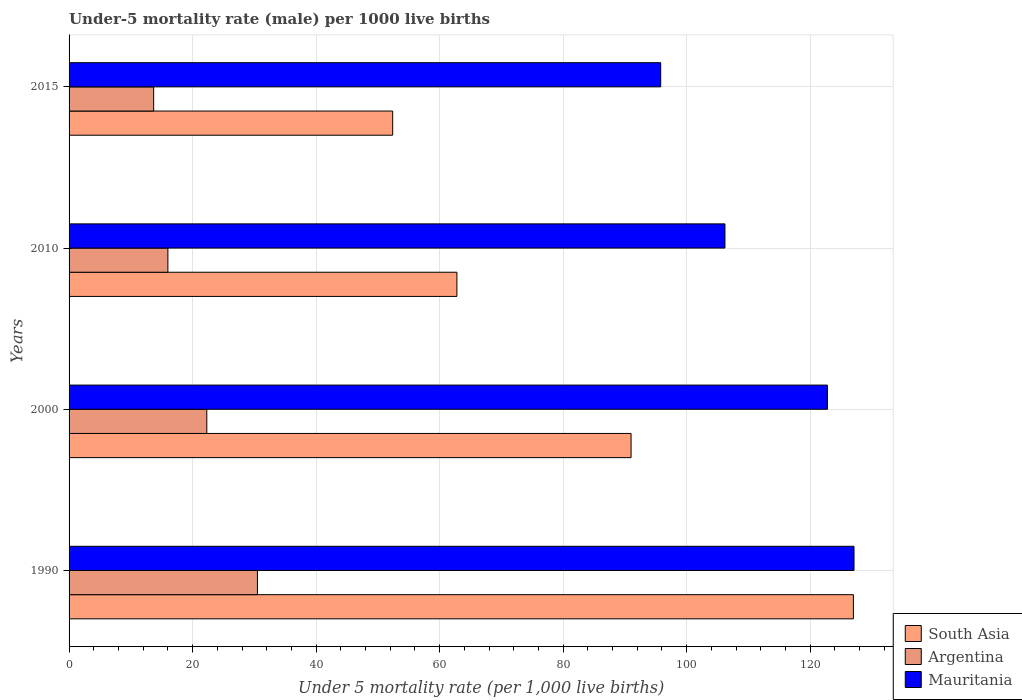Are the number of bars per tick equal to the number of legend labels?
Make the answer very short. Yes. In how many cases, is the number of bars for a given year not equal to the number of legend labels?
Provide a short and direct response. 0. What is the under-five mortality rate in Argentina in 1990?
Ensure brevity in your answer.  30.5. Across all years, what is the maximum under-five mortality rate in Argentina?
Give a very brief answer. 30.5. In which year was the under-five mortality rate in Mauritania maximum?
Your response must be concise. 1990. In which year was the under-five mortality rate in South Asia minimum?
Provide a succinct answer. 2015. What is the total under-five mortality rate in Argentina in the graph?
Provide a short and direct response. 82.5. What is the difference between the under-five mortality rate in Argentina in 1990 and that in 2010?
Your answer should be very brief. 14.5. What is the difference between the under-five mortality rate in South Asia in 2000 and the under-five mortality rate in Argentina in 2015?
Provide a succinct answer. 77.3. What is the average under-five mortality rate in Mauritania per year?
Your answer should be very brief. 112.97. In the year 2000, what is the difference between the under-five mortality rate in South Asia and under-five mortality rate in Mauritania?
Give a very brief answer. -31.8. What is the ratio of the under-five mortality rate in Argentina in 2000 to that in 2010?
Your answer should be compact. 1.39. Is the under-five mortality rate in Mauritania in 1990 less than that in 2010?
Your answer should be compact. No. What is the difference between the highest and the second highest under-five mortality rate in Argentina?
Provide a succinct answer. 8.2. What is the difference between the highest and the lowest under-five mortality rate in Argentina?
Offer a very short reply. 16.8. In how many years, is the under-five mortality rate in South Asia greater than the average under-five mortality rate in South Asia taken over all years?
Make the answer very short. 2. What does the 1st bar from the top in 2000 represents?
Ensure brevity in your answer.  Mauritania. How many bars are there?
Keep it short and to the point. 12. Are the values on the major ticks of X-axis written in scientific E-notation?
Make the answer very short. No. Does the graph contain grids?
Your answer should be very brief. Yes. Where does the legend appear in the graph?
Your answer should be very brief. Bottom right. How are the legend labels stacked?
Provide a succinct answer. Vertical. What is the title of the graph?
Keep it short and to the point. Under-5 mortality rate (male) per 1000 live births. What is the label or title of the X-axis?
Your answer should be compact. Under 5 mortality rate (per 1,0 live births). What is the Under 5 mortality rate (per 1,000 live births) in South Asia in 1990?
Your answer should be compact. 127. What is the Under 5 mortality rate (per 1,000 live births) of Argentina in 1990?
Keep it short and to the point. 30.5. What is the Under 5 mortality rate (per 1,000 live births) in Mauritania in 1990?
Your response must be concise. 127.1. What is the Under 5 mortality rate (per 1,000 live births) of South Asia in 2000?
Provide a succinct answer. 91. What is the Under 5 mortality rate (per 1,000 live births) in Argentina in 2000?
Your answer should be very brief. 22.3. What is the Under 5 mortality rate (per 1,000 live births) in Mauritania in 2000?
Make the answer very short. 122.8. What is the Under 5 mortality rate (per 1,000 live births) in South Asia in 2010?
Make the answer very short. 62.8. What is the Under 5 mortality rate (per 1,000 live births) in Argentina in 2010?
Your response must be concise. 16. What is the Under 5 mortality rate (per 1,000 live births) of Mauritania in 2010?
Keep it short and to the point. 106.2. What is the Under 5 mortality rate (per 1,000 live births) in South Asia in 2015?
Your response must be concise. 52.4. What is the Under 5 mortality rate (per 1,000 live births) in Argentina in 2015?
Offer a very short reply. 13.7. What is the Under 5 mortality rate (per 1,000 live births) in Mauritania in 2015?
Your response must be concise. 95.8. Across all years, what is the maximum Under 5 mortality rate (per 1,000 live births) of South Asia?
Provide a short and direct response. 127. Across all years, what is the maximum Under 5 mortality rate (per 1,000 live births) of Argentina?
Keep it short and to the point. 30.5. Across all years, what is the maximum Under 5 mortality rate (per 1,000 live births) of Mauritania?
Offer a terse response. 127.1. Across all years, what is the minimum Under 5 mortality rate (per 1,000 live births) in South Asia?
Your answer should be very brief. 52.4. Across all years, what is the minimum Under 5 mortality rate (per 1,000 live births) of Mauritania?
Ensure brevity in your answer.  95.8. What is the total Under 5 mortality rate (per 1,000 live births) of South Asia in the graph?
Make the answer very short. 333.2. What is the total Under 5 mortality rate (per 1,000 live births) of Argentina in the graph?
Your answer should be compact. 82.5. What is the total Under 5 mortality rate (per 1,000 live births) in Mauritania in the graph?
Ensure brevity in your answer.  451.9. What is the difference between the Under 5 mortality rate (per 1,000 live births) of South Asia in 1990 and that in 2000?
Provide a short and direct response. 36. What is the difference between the Under 5 mortality rate (per 1,000 live births) of Mauritania in 1990 and that in 2000?
Provide a short and direct response. 4.3. What is the difference between the Under 5 mortality rate (per 1,000 live births) in South Asia in 1990 and that in 2010?
Provide a succinct answer. 64.2. What is the difference between the Under 5 mortality rate (per 1,000 live births) in Mauritania in 1990 and that in 2010?
Provide a succinct answer. 20.9. What is the difference between the Under 5 mortality rate (per 1,000 live births) in South Asia in 1990 and that in 2015?
Your response must be concise. 74.6. What is the difference between the Under 5 mortality rate (per 1,000 live births) of Argentina in 1990 and that in 2015?
Provide a succinct answer. 16.8. What is the difference between the Under 5 mortality rate (per 1,000 live births) in Mauritania in 1990 and that in 2015?
Keep it short and to the point. 31.3. What is the difference between the Under 5 mortality rate (per 1,000 live births) of South Asia in 2000 and that in 2010?
Your answer should be very brief. 28.2. What is the difference between the Under 5 mortality rate (per 1,000 live births) of Mauritania in 2000 and that in 2010?
Provide a succinct answer. 16.6. What is the difference between the Under 5 mortality rate (per 1,000 live births) in South Asia in 2000 and that in 2015?
Make the answer very short. 38.6. What is the difference between the Under 5 mortality rate (per 1,000 live births) in Mauritania in 2000 and that in 2015?
Keep it short and to the point. 27. What is the difference between the Under 5 mortality rate (per 1,000 live births) in South Asia in 2010 and that in 2015?
Offer a very short reply. 10.4. What is the difference between the Under 5 mortality rate (per 1,000 live births) of Mauritania in 2010 and that in 2015?
Provide a short and direct response. 10.4. What is the difference between the Under 5 mortality rate (per 1,000 live births) of South Asia in 1990 and the Under 5 mortality rate (per 1,000 live births) of Argentina in 2000?
Your answer should be compact. 104.7. What is the difference between the Under 5 mortality rate (per 1,000 live births) in Argentina in 1990 and the Under 5 mortality rate (per 1,000 live births) in Mauritania in 2000?
Your answer should be compact. -92.3. What is the difference between the Under 5 mortality rate (per 1,000 live births) of South Asia in 1990 and the Under 5 mortality rate (per 1,000 live births) of Argentina in 2010?
Give a very brief answer. 111. What is the difference between the Under 5 mortality rate (per 1,000 live births) in South Asia in 1990 and the Under 5 mortality rate (per 1,000 live births) in Mauritania in 2010?
Your answer should be very brief. 20.8. What is the difference between the Under 5 mortality rate (per 1,000 live births) in Argentina in 1990 and the Under 5 mortality rate (per 1,000 live births) in Mauritania in 2010?
Keep it short and to the point. -75.7. What is the difference between the Under 5 mortality rate (per 1,000 live births) in South Asia in 1990 and the Under 5 mortality rate (per 1,000 live births) in Argentina in 2015?
Your response must be concise. 113.3. What is the difference between the Under 5 mortality rate (per 1,000 live births) of South Asia in 1990 and the Under 5 mortality rate (per 1,000 live births) of Mauritania in 2015?
Offer a very short reply. 31.2. What is the difference between the Under 5 mortality rate (per 1,000 live births) in Argentina in 1990 and the Under 5 mortality rate (per 1,000 live births) in Mauritania in 2015?
Provide a short and direct response. -65.3. What is the difference between the Under 5 mortality rate (per 1,000 live births) of South Asia in 2000 and the Under 5 mortality rate (per 1,000 live births) of Argentina in 2010?
Your answer should be very brief. 75. What is the difference between the Under 5 mortality rate (per 1,000 live births) of South Asia in 2000 and the Under 5 mortality rate (per 1,000 live births) of Mauritania in 2010?
Your answer should be very brief. -15.2. What is the difference between the Under 5 mortality rate (per 1,000 live births) in Argentina in 2000 and the Under 5 mortality rate (per 1,000 live births) in Mauritania in 2010?
Your answer should be compact. -83.9. What is the difference between the Under 5 mortality rate (per 1,000 live births) in South Asia in 2000 and the Under 5 mortality rate (per 1,000 live births) in Argentina in 2015?
Provide a succinct answer. 77.3. What is the difference between the Under 5 mortality rate (per 1,000 live births) in South Asia in 2000 and the Under 5 mortality rate (per 1,000 live births) in Mauritania in 2015?
Ensure brevity in your answer.  -4.8. What is the difference between the Under 5 mortality rate (per 1,000 live births) of Argentina in 2000 and the Under 5 mortality rate (per 1,000 live births) of Mauritania in 2015?
Give a very brief answer. -73.5. What is the difference between the Under 5 mortality rate (per 1,000 live births) of South Asia in 2010 and the Under 5 mortality rate (per 1,000 live births) of Argentina in 2015?
Provide a succinct answer. 49.1. What is the difference between the Under 5 mortality rate (per 1,000 live births) of South Asia in 2010 and the Under 5 mortality rate (per 1,000 live births) of Mauritania in 2015?
Offer a very short reply. -33. What is the difference between the Under 5 mortality rate (per 1,000 live births) of Argentina in 2010 and the Under 5 mortality rate (per 1,000 live births) of Mauritania in 2015?
Make the answer very short. -79.8. What is the average Under 5 mortality rate (per 1,000 live births) of South Asia per year?
Keep it short and to the point. 83.3. What is the average Under 5 mortality rate (per 1,000 live births) of Argentina per year?
Keep it short and to the point. 20.62. What is the average Under 5 mortality rate (per 1,000 live births) of Mauritania per year?
Provide a short and direct response. 112.97. In the year 1990, what is the difference between the Under 5 mortality rate (per 1,000 live births) in South Asia and Under 5 mortality rate (per 1,000 live births) in Argentina?
Keep it short and to the point. 96.5. In the year 1990, what is the difference between the Under 5 mortality rate (per 1,000 live births) in Argentina and Under 5 mortality rate (per 1,000 live births) in Mauritania?
Your response must be concise. -96.6. In the year 2000, what is the difference between the Under 5 mortality rate (per 1,000 live births) in South Asia and Under 5 mortality rate (per 1,000 live births) in Argentina?
Offer a terse response. 68.7. In the year 2000, what is the difference between the Under 5 mortality rate (per 1,000 live births) of South Asia and Under 5 mortality rate (per 1,000 live births) of Mauritania?
Your response must be concise. -31.8. In the year 2000, what is the difference between the Under 5 mortality rate (per 1,000 live births) of Argentina and Under 5 mortality rate (per 1,000 live births) of Mauritania?
Offer a terse response. -100.5. In the year 2010, what is the difference between the Under 5 mortality rate (per 1,000 live births) in South Asia and Under 5 mortality rate (per 1,000 live births) in Argentina?
Your response must be concise. 46.8. In the year 2010, what is the difference between the Under 5 mortality rate (per 1,000 live births) of South Asia and Under 5 mortality rate (per 1,000 live births) of Mauritania?
Ensure brevity in your answer.  -43.4. In the year 2010, what is the difference between the Under 5 mortality rate (per 1,000 live births) in Argentina and Under 5 mortality rate (per 1,000 live births) in Mauritania?
Your response must be concise. -90.2. In the year 2015, what is the difference between the Under 5 mortality rate (per 1,000 live births) in South Asia and Under 5 mortality rate (per 1,000 live births) in Argentina?
Keep it short and to the point. 38.7. In the year 2015, what is the difference between the Under 5 mortality rate (per 1,000 live births) of South Asia and Under 5 mortality rate (per 1,000 live births) of Mauritania?
Offer a very short reply. -43.4. In the year 2015, what is the difference between the Under 5 mortality rate (per 1,000 live births) in Argentina and Under 5 mortality rate (per 1,000 live births) in Mauritania?
Provide a succinct answer. -82.1. What is the ratio of the Under 5 mortality rate (per 1,000 live births) of South Asia in 1990 to that in 2000?
Make the answer very short. 1.4. What is the ratio of the Under 5 mortality rate (per 1,000 live births) in Argentina in 1990 to that in 2000?
Offer a terse response. 1.37. What is the ratio of the Under 5 mortality rate (per 1,000 live births) of Mauritania in 1990 to that in 2000?
Your answer should be very brief. 1.03. What is the ratio of the Under 5 mortality rate (per 1,000 live births) of South Asia in 1990 to that in 2010?
Ensure brevity in your answer.  2.02. What is the ratio of the Under 5 mortality rate (per 1,000 live births) in Argentina in 1990 to that in 2010?
Provide a short and direct response. 1.91. What is the ratio of the Under 5 mortality rate (per 1,000 live births) of Mauritania in 1990 to that in 2010?
Keep it short and to the point. 1.2. What is the ratio of the Under 5 mortality rate (per 1,000 live births) in South Asia in 1990 to that in 2015?
Ensure brevity in your answer.  2.42. What is the ratio of the Under 5 mortality rate (per 1,000 live births) in Argentina in 1990 to that in 2015?
Keep it short and to the point. 2.23. What is the ratio of the Under 5 mortality rate (per 1,000 live births) in Mauritania in 1990 to that in 2015?
Provide a short and direct response. 1.33. What is the ratio of the Under 5 mortality rate (per 1,000 live births) of South Asia in 2000 to that in 2010?
Provide a short and direct response. 1.45. What is the ratio of the Under 5 mortality rate (per 1,000 live births) of Argentina in 2000 to that in 2010?
Ensure brevity in your answer.  1.39. What is the ratio of the Under 5 mortality rate (per 1,000 live births) of Mauritania in 2000 to that in 2010?
Your answer should be very brief. 1.16. What is the ratio of the Under 5 mortality rate (per 1,000 live births) of South Asia in 2000 to that in 2015?
Make the answer very short. 1.74. What is the ratio of the Under 5 mortality rate (per 1,000 live births) in Argentina in 2000 to that in 2015?
Provide a succinct answer. 1.63. What is the ratio of the Under 5 mortality rate (per 1,000 live births) of Mauritania in 2000 to that in 2015?
Your answer should be very brief. 1.28. What is the ratio of the Under 5 mortality rate (per 1,000 live births) in South Asia in 2010 to that in 2015?
Ensure brevity in your answer.  1.2. What is the ratio of the Under 5 mortality rate (per 1,000 live births) in Argentina in 2010 to that in 2015?
Keep it short and to the point. 1.17. What is the ratio of the Under 5 mortality rate (per 1,000 live births) of Mauritania in 2010 to that in 2015?
Give a very brief answer. 1.11. What is the difference between the highest and the second highest Under 5 mortality rate (per 1,000 live births) in South Asia?
Offer a terse response. 36. What is the difference between the highest and the lowest Under 5 mortality rate (per 1,000 live births) of South Asia?
Offer a very short reply. 74.6. What is the difference between the highest and the lowest Under 5 mortality rate (per 1,000 live births) in Argentina?
Keep it short and to the point. 16.8. What is the difference between the highest and the lowest Under 5 mortality rate (per 1,000 live births) in Mauritania?
Provide a short and direct response. 31.3. 